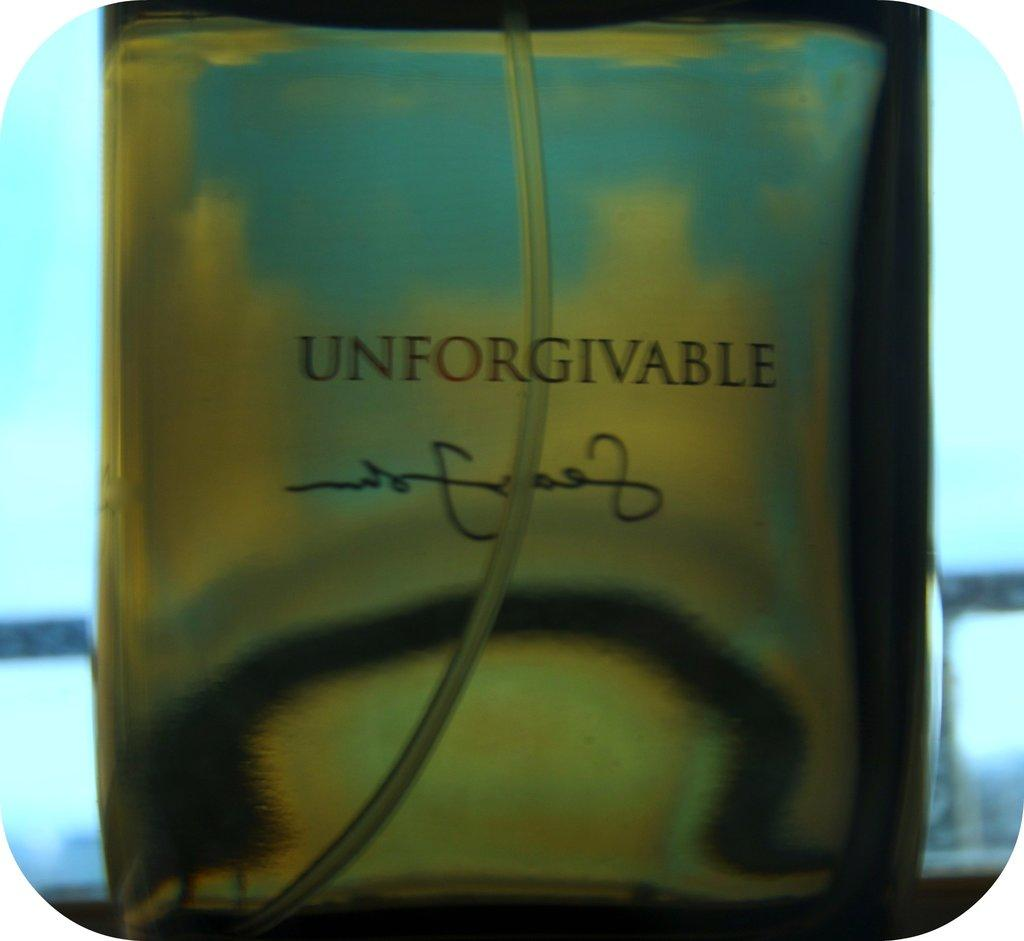<image>
Describe the image concisely. A spray bottle of Unforgiveable cologne in a close up view. 